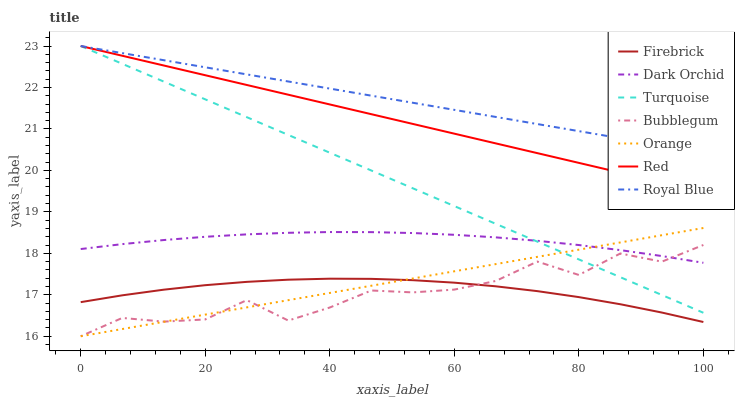Does Bubblegum have the minimum area under the curve?
Answer yes or no. Yes. Does Royal Blue have the maximum area under the curve?
Answer yes or no. Yes. Does Firebrick have the minimum area under the curve?
Answer yes or no. No. Does Firebrick have the maximum area under the curve?
Answer yes or no. No. Is Turquoise the smoothest?
Answer yes or no. Yes. Is Bubblegum the roughest?
Answer yes or no. Yes. Is Firebrick the smoothest?
Answer yes or no. No. Is Firebrick the roughest?
Answer yes or no. No. Does Firebrick have the lowest value?
Answer yes or no. No. Does Red have the highest value?
Answer yes or no. Yes. Does Bubblegum have the highest value?
Answer yes or no. No. Is Firebrick less than Dark Orchid?
Answer yes or no. Yes. Is Dark Orchid greater than Firebrick?
Answer yes or no. Yes. Does Bubblegum intersect Orange?
Answer yes or no. Yes. Is Bubblegum less than Orange?
Answer yes or no. No. Is Bubblegum greater than Orange?
Answer yes or no. No. Does Firebrick intersect Dark Orchid?
Answer yes or no. No. 